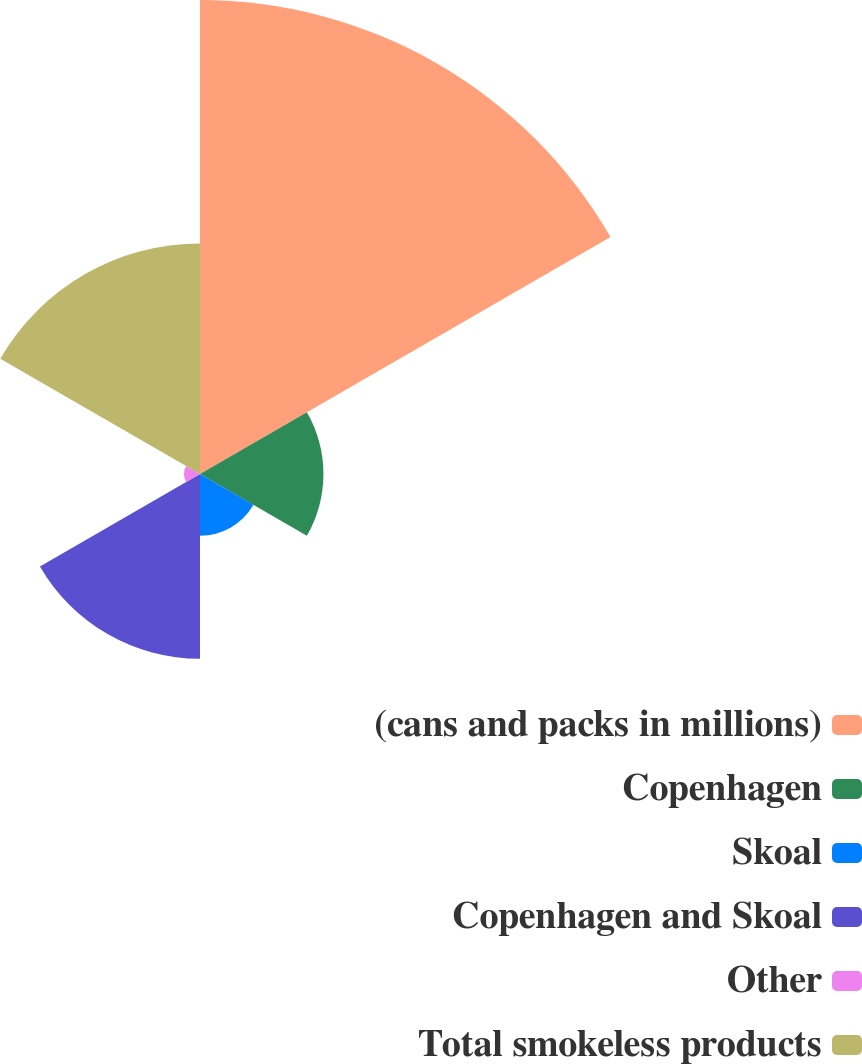Convert chart. <chart><loc_0><loc_0><loc_500><loc_500><pie_chart><fcel>(cans and packs in millions)<fcel>Copenhagen<fcel>Skoal<fcel>Copenhagen and Skoal<fcel>Other<fcel>Total smokeless products<nl><fcel>43.47%<fcel>11.32%<fcel>5.66%<fcel>16.95%<fcel>1.46%<fcel>21.15%<nl></chart> 